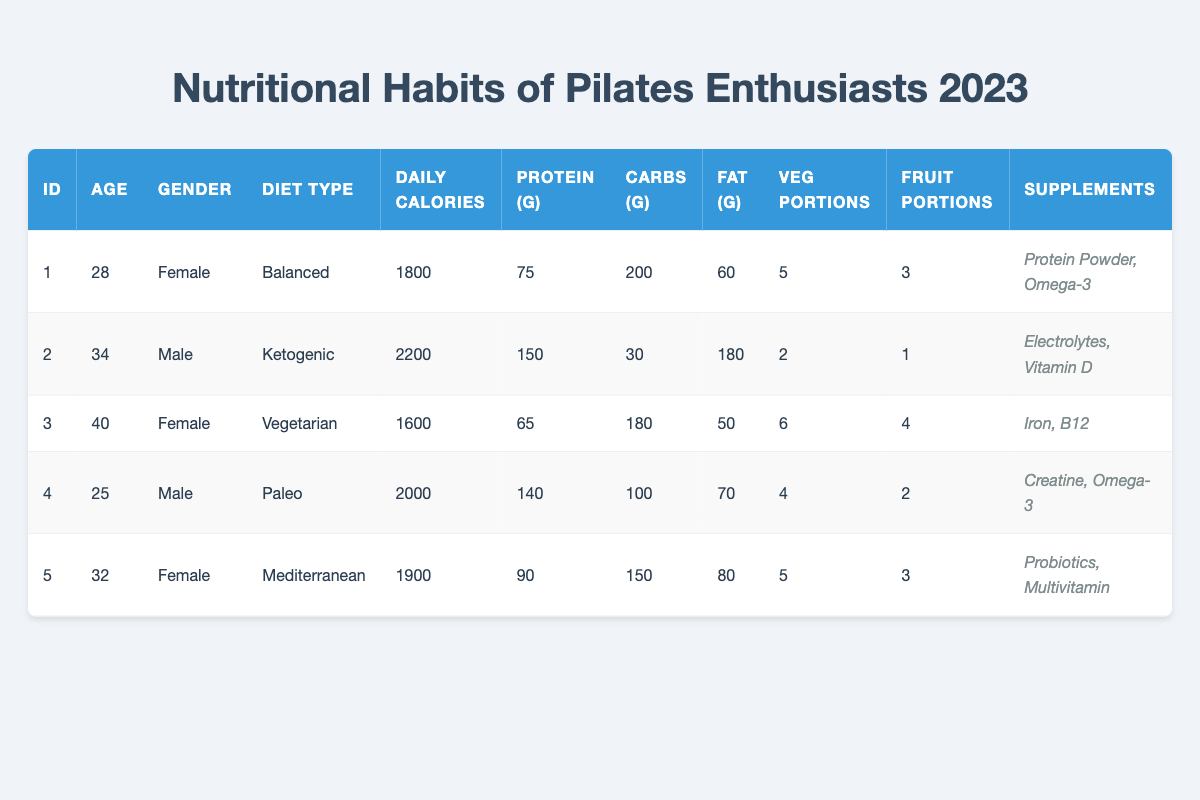What is the age of the youngest Pilates enthusiast in the survey? The youngest enthusiast, identified by EnthusiastID 4, is 25 years old. This can be found by comparing the ages listed in the table.
Answer: 25 How many total fat (g) is consumed by all Pilates enthusiasts surveyed? To find the total fat intake, add the fat intake of all enthusiasts: 60 + 180 + 50 + 70 + 80 = 440.
Answer: 440 Is there a vegetarian Pilates enthusiast in the survey? Yes, based on the data, EnthusiastID 3 is identified as vegetarian. This confirms that there is at least one vegetarian in the group.
Answer: Yes What is the average daily calorie intake of the Pilates enthusiasts surveyed? First, sum the daily calorie intake: 1800 + 2200 + 1600 + 2000 + 1900 = 11500. Then, divide by the number of enthusiasts (5): 11500 / 5 = 2300.
Answer: 2300 Which diet type has the highest protein intake? The highest protein intake is 150 grams in the Ketogenic diet (EnthusiastID 2), which can be identified by comparing the protein intake values across diet types.
Answer: Ketogenic What percentage of the Pilates enthusiasts use supplements? Four out of five enthusiasts (EnthusiastIDs 1, 2, 3, 4, and 5) use supplements. Therefore, (4 / 5) * 100 = 80%.
Answer: 80% What is the total number of vegetable portions consumed by female Pilates enthusiasts in the survey? The female enthusiasts are EnthusiastIDs 1, 3, and 5. Their vegetable portions are 5, 6, and 5 respectively, so adding these: 5 + 6 + 5 = 16.
Answer: 16 Do any Pilates enthusiasts consume more than 2000 daily calories? Yes, EnthusiastID 2 consumes 2200 daily calories, and EnthusiastID 4 consumes 2000, both above 2000 calories.
Answer: Yes What is the average carbohydrate intake among the surveyed Pilates enthusiasts? Sum carbohydrates: 200 + 30 + 180 + 100 + 150 = 660. Then divide by the number of enthusiasts (5): 660 / 5 = 132.
Answer: 132 